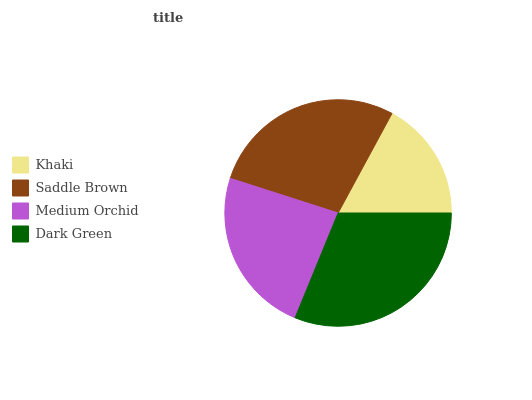Is Khaki the minimum?
Answer yes or no. Yes. Is Dark Green the maximum?
Answer yes or no. Yes. Is Saddle Brown the minimum?
Answer yes or no. No. Is Saddle Brown the maximum?
Answer yes or no. No. Is Saddle Brown greater than Khaki?
Answer yes or no. Yes. Is Khaki less than Saddle Brown?
Answer yes or no. Yes. Is Khaki greater than Saddle Brown?
Answer yes or no. No. Is Saddle Brown less than Khaki?
Answer yes or no. No. Is Saddle Brown the high median?
Answer yes or no. Yes. Is Medium Orchid the low median?
Answer yes or no. Yes. Is Medium Orchid the high median?
Answer yes or no. No. Is Saddle Brown the low median?
Answer yes or no. No. 